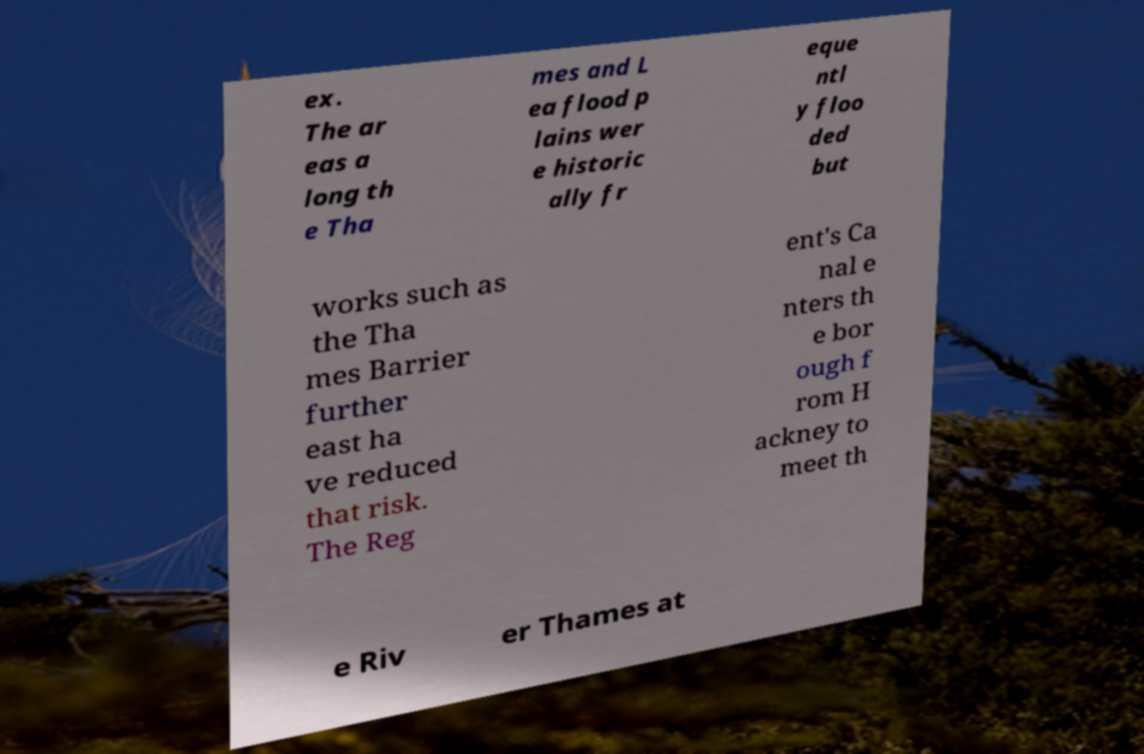Please read and relay the text visible in this image. What does it say? ex. The ar eas a long th e Tha mes and L ea flood p lains wer e historic ally fr eque ntl y floo ded but works such as the Tha mes Barrier further east ha ve reduced that risk. The Reg ent's Ca nal e nters th e bor ough f rom H ackney to meet th e Riv er Thames at 